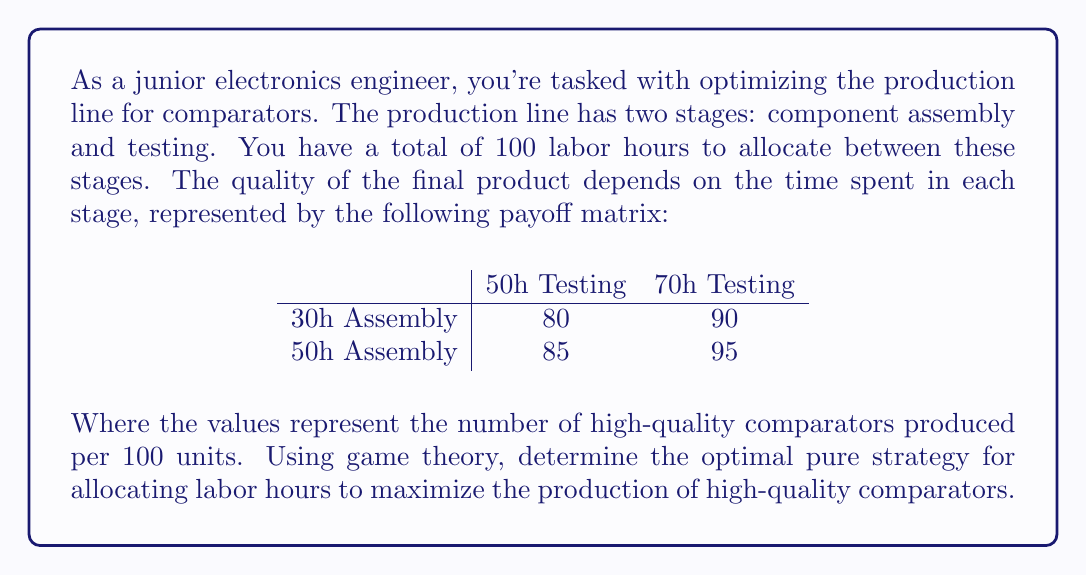Can you solve this math problem? To solve this problem using game theory, we'll follow these steps:

1) First, we need to identify the players and strategies:
   - Player 1: Assembly stage (rows)
   - Player 2: Testing stage (columns)
   - Strategies: The different time allocations for each stage

2) The payoff matrix is already given in the question. Each cell represents the number of high-quality comparators produced per 100 units.

3) In game theory, we typically look for a Nash equilibrium, where neither player can unilaterally improve their outcome by changing their strategy.

4) To find the Nash equilibrium, we'll use the dominance method:

   For Player 1 (Assembly):
   - 50h Assembly dominates 30h Assembly (85 > 80 and 95 > 90)

   For Player 2 (Testing):
   - 70h Testing dominates 50h Testing (90 > 80 and 95 > 85)

5) After eliminating dominated strategies, we're left with one cell:
   (50h Assembly, 70h Testing) with a payoff of 95

6) This is the Nash equilibrium and represents the optimal pure strategy for both stages.

7) We need to verify if this allocation is feasible given the total 100 labor hours constraint:
   50h (Assembly) + 70h (Testing) = 120h > 100h

   Unfortunately, this optimal strategy exceeds the available labor hours.

8) Given this constraint, we need to choose the next best feasible strategy:
   (50h Assembly, 50h Testing) with a payoff of 85

This strategy uses exactly 100 labor hours and produces the highest number of high-quality comparators among the feasible options.
Answer: The optimal pure strategy for allocating labor hours in the comparator production line is 50 hours for assembly and 50 hours for testing, resulting in 85 high-quality comparators produced per 100 units. 